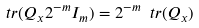Convert formula to latex. <formula><loc_0><loc_0><loc_500><loc_500>\ t r ( Q _ { x } 2 ^ { - m } I _ { m } ) = 2 ^ { - m } \ t r ( Q _ { x } )</formula> 